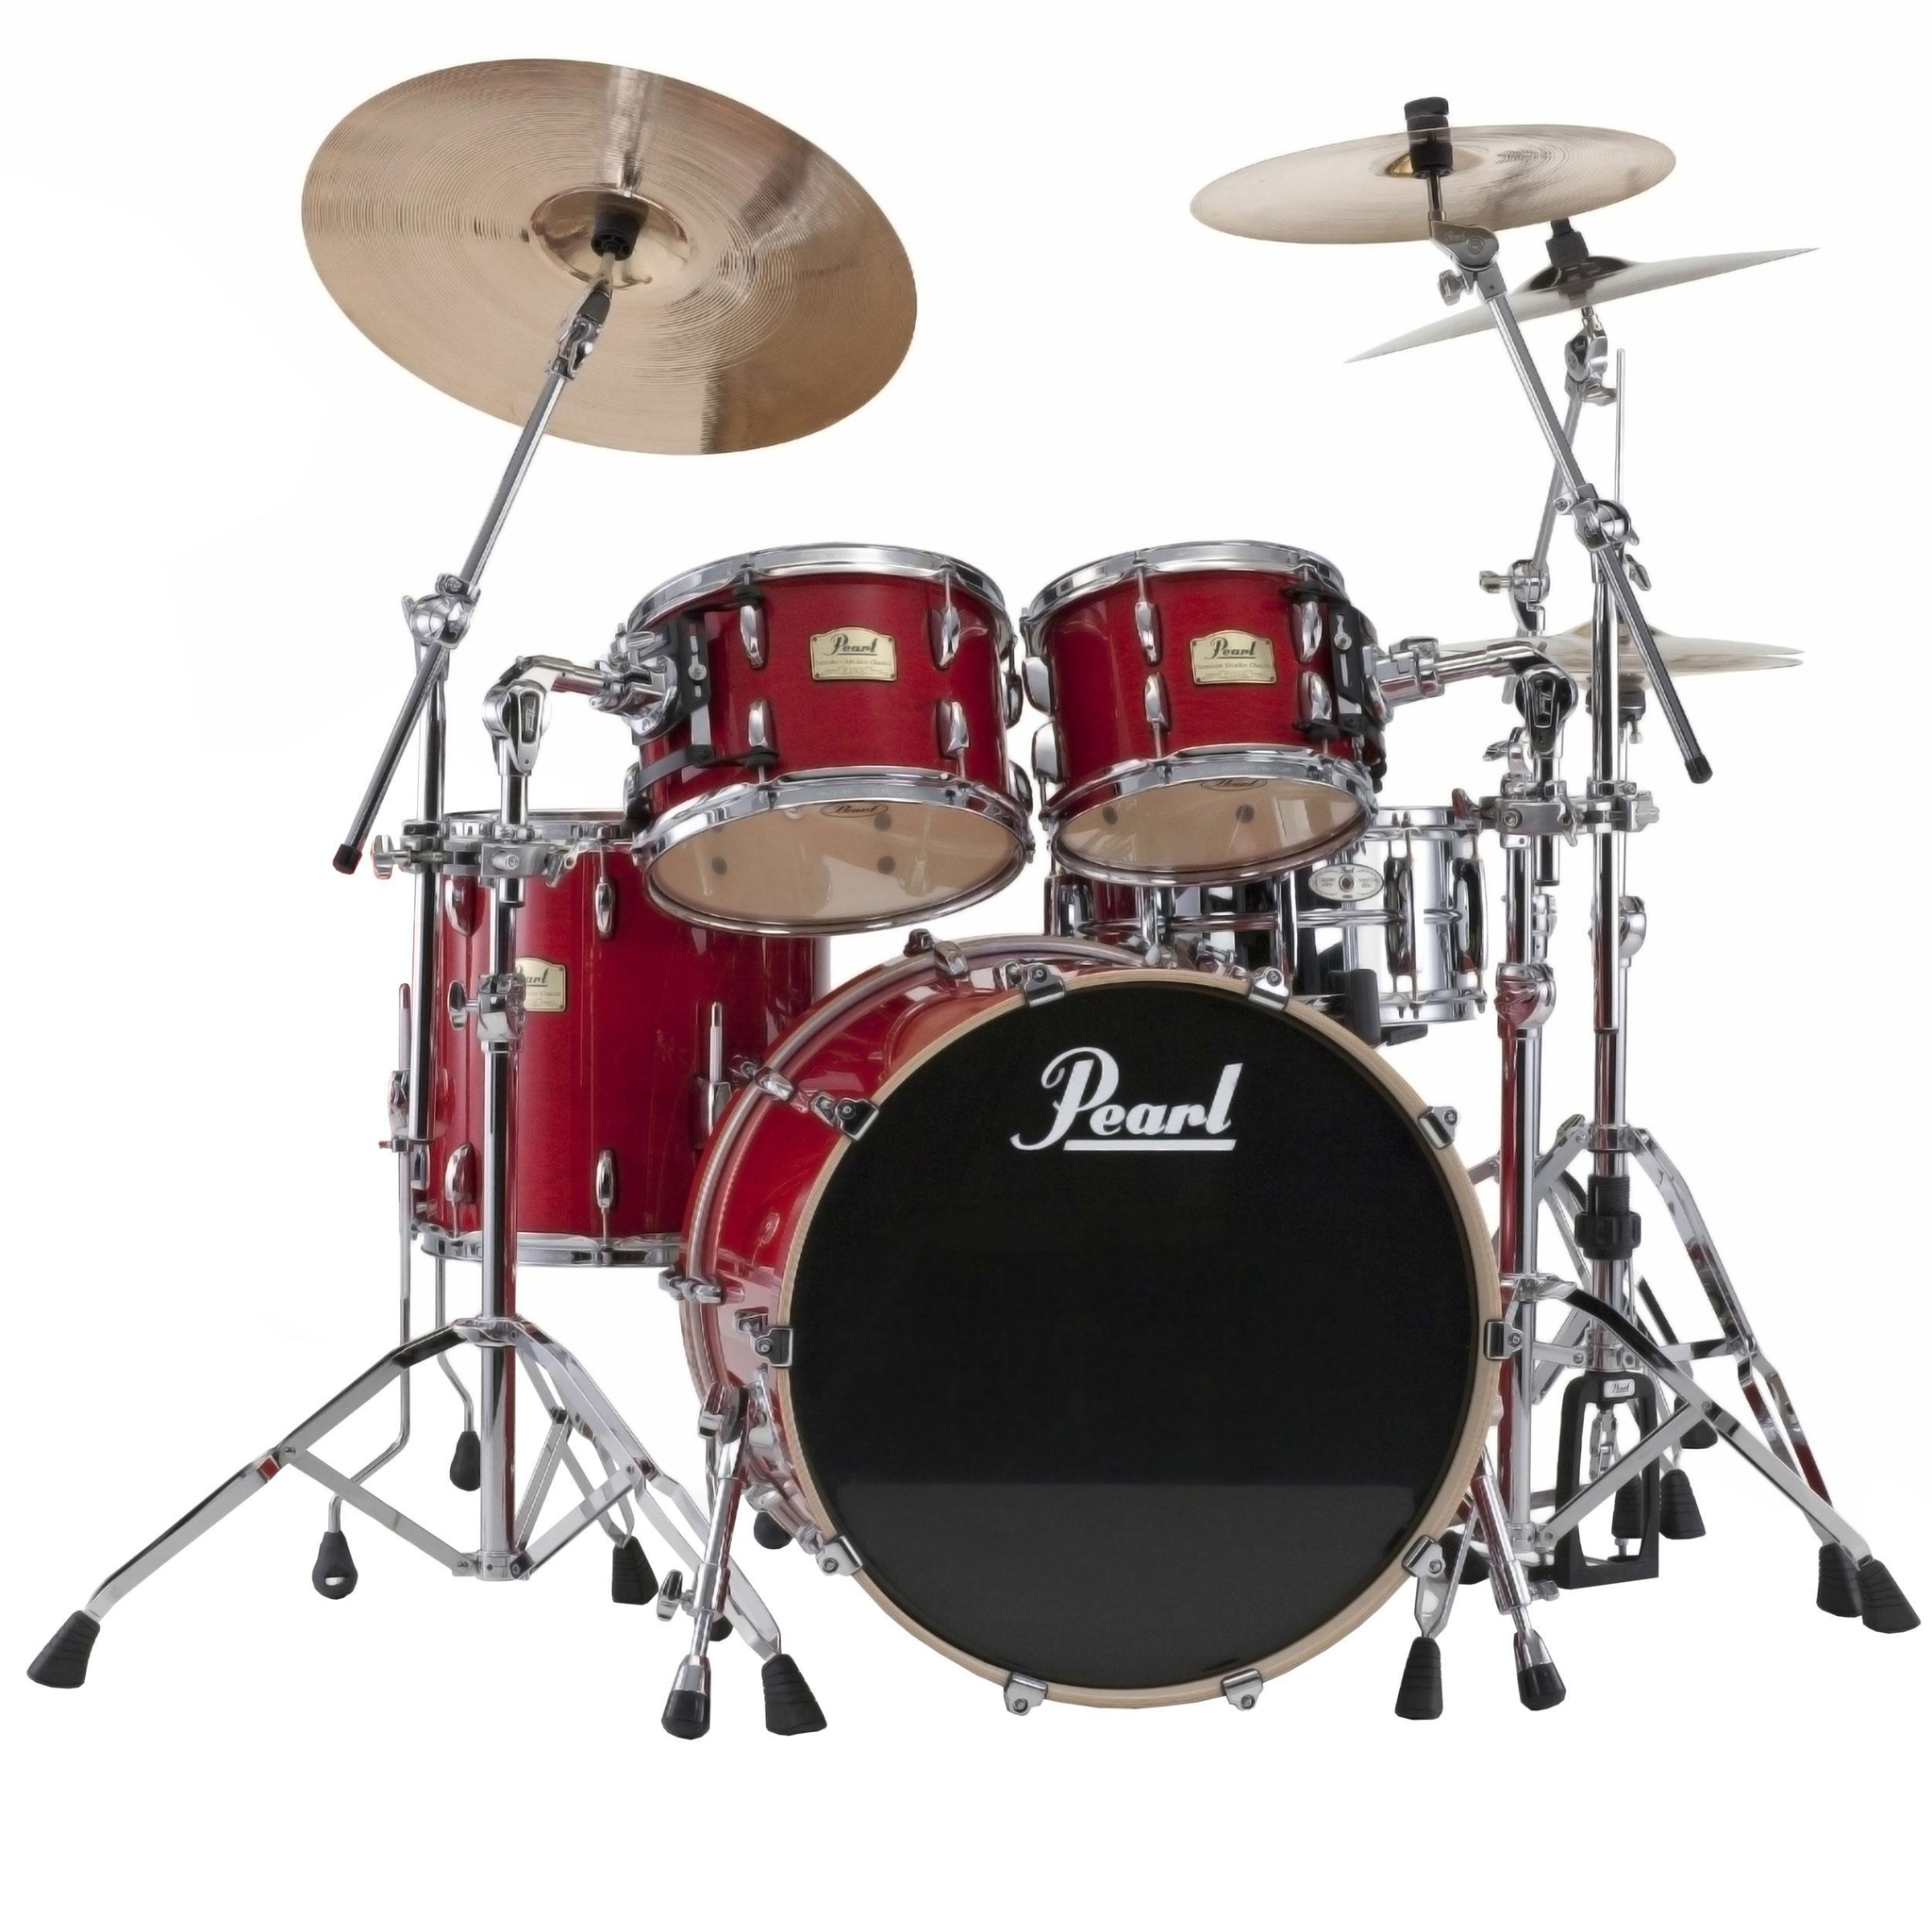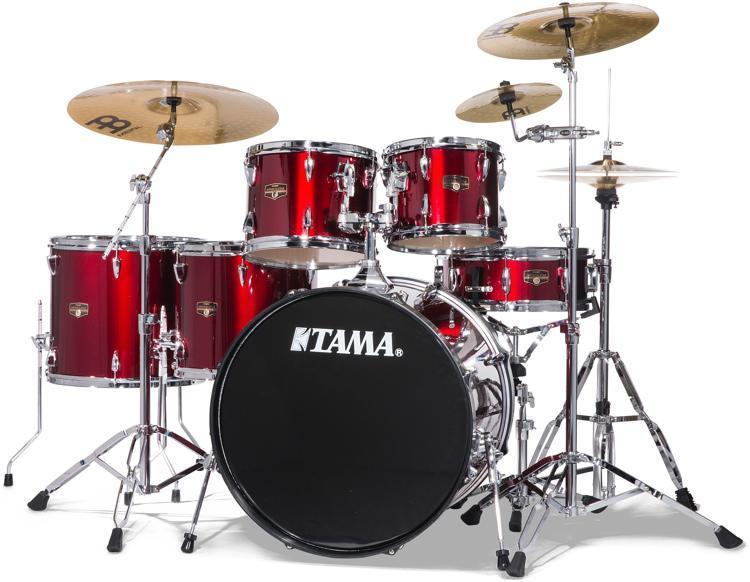The first image is the image on the left, the second image is the image on the right. Analyze the images presented: Is the assertion "The right image contains a drum kit that is predominately red." valid? Answer yes or no. Yes. The first image is the image on the left, the second image is the image on the right. Assess this claim about the two images: "Two drum kits in different sizes are shown, both with red drum facings and at least one forward-facing black drum.". Correct or not? Answer yes or no. Yes. 